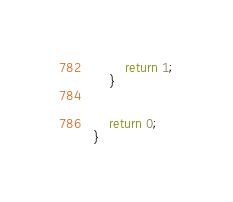<code> <loc_0><loc_0><loc_500><loc_500><_C++_>
		return 1;
	}
	

	return 0;
}
</code> 